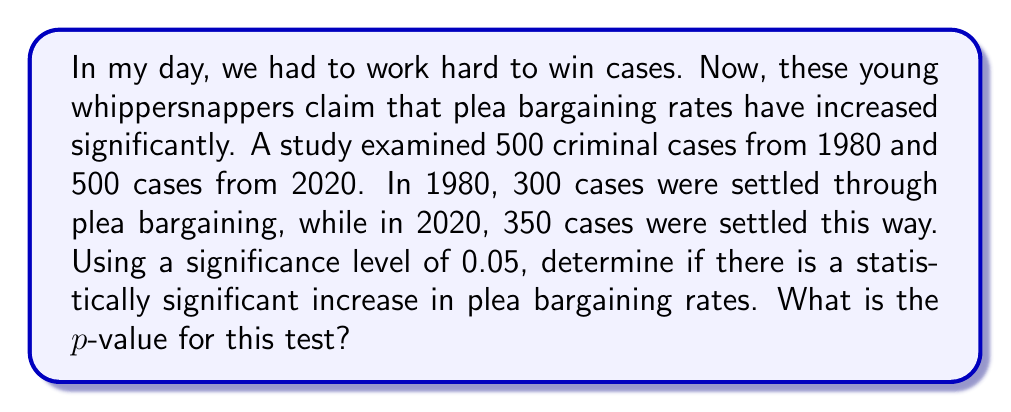What is the answer to this math problem? To determine if there's a statistically significant increase in plea bargaining rates, we'll use a two-proportion z-test.

Step 1: State the hypotheses
$H_0: p_1 = p_2$ (no difference in proportions)
$H_a: p_1 < p_2$ (proportion in 2020 is greater)

Step 2: Calculate the sample proportions
$\hat{p}_1 = 300/500 = 0.6$ (1980)
$\hat{p}_2 = 350/500 = 0.7$ (2020)

Step 3: Calculate the pooled proportion
$$\hat{p} = \frac{300 + 350}{500 + 500} = \frac{650}{1000} = 0.65$$

Step 4: Calculate the standard error
$$SE = \sqrt{\hat{p}(1-\hat{p})(\frac{1}{n_1} + \frac{1}{n_2})}$$
$$SE = \sqrt{0.65(1-0.65)(\frac{1}{500} + \frac{1}{500})} \approx 0.0301$$

Step 5: Calculate the z-statistic
$$z = \frac{\hat{p}_2 - \hat{p}_1}{SE} = \frac{0.7 - 0.6}{0.0301} \approx 3.32$$

Step 6: Find the p-value
Using a standard normal distribution table or calculator, we find:
$$p\text{-value} = P(Z < 3.32) \approx 0.0004$$

Step 7: Compare p-value to significance level
Since $0.0004 < 0.05$, we reject the null hypothesis.
Answer: $p\text{-value} \approx 0.0004$ 